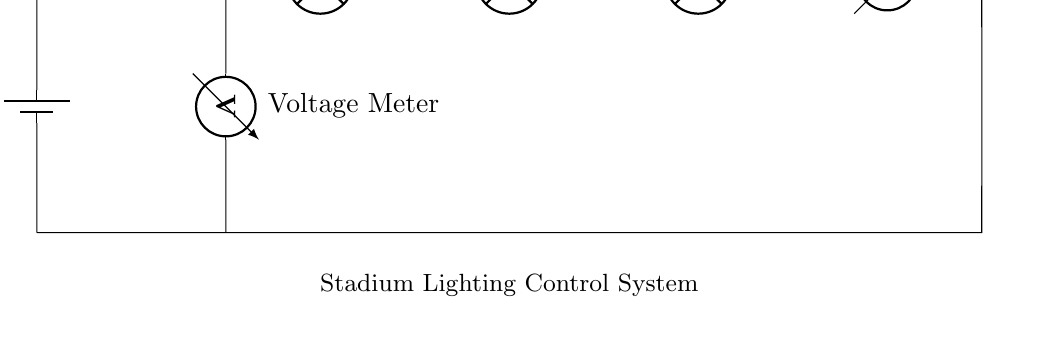What is the main switch labeled as? The main switch is labeled as "Main Switch", which can be observed directly in the circuit diagram next to the switch symbol.
Answer: Main Switch How many stadium lights are present in the circuit? The circuit diagram displays three lamp symbols labeled as "Stadium Light 1", "Stadium Light 2", and "Stadium Light 3", indicating there are three stadium lights connected in series.
Answer: Three What type of measurement does the current meter provide? The current meter is used to measure the current flowing through the circuit, as indicated by its label "Current Meter".
Answer: Current What is the role of the voltmeter in this circuit? The voltmeter measures the voltage across the main switch, shown in the circuit diagram labeled as "Voltage Meter", which indicates its location and purpose in measuring potential difference.
Answer: Voltage Is this a parallel or series circuit? The circuit consists of components connected end-to-end without any branching, which defines a series circuit arrangement.
Answer: Series What happens when the main switch is turned off? When the main switch is turned off, the circuit is broken, preventing current from flowing through the stadium lights and the current meter, thus turning off the lights.
Answer: Lights off What is the voltage source labeled as? The voltage source is labeled as "V supply", indicating the power supply’s role in supplying voltage for the entire circuit.
Answer: V supply 